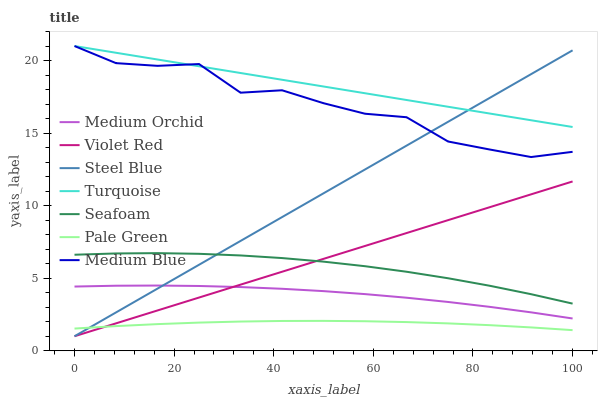Does Pale Green have the minimum area under the curve?
Answer yes or no. Yes. Does Turquoise have the maximum area under the curve?
Answer yes or no. Yes. Does Medium Orchid have the minimum area under the curve?
Answer yes or no. No. Does Medium Orchid have the maximum area under the curve?
Answer yes or no. No. Is Violet Red the smoothest?
Answer yes or no. Yes. Is Medium Blue the roughest?
Answer yes or no. Yes. Is Medium Orchid the smoothest?
Answer yes or no. No. Is Medium Orchid the roughest?
Answer yes or no. No. Does Violet Red have the lowest value?
Answer yes or no. Yes. Does Medium Orchid have the lowest value?
Answer yes or no. No. Does Turquoise have the highest value?
Answer yes or no. Yes. Does Medium Orchid have the highest value?
Answer yes or no. No. Is Pale Green less than Turquoise?
Answer yes or no. Yes. Is Medium Blue greater than Seafoam?
Answer yes or no. Yes. Does Medium Blue intersect Turquoise?
Answer yes or no. Yes. Is Medium Blue less than Turquoise?
Answer yes or no. No. Is Medium Blue greater than Turquoise?
Answer yes or no. No. Does Pale Green intersect Turquoise?
Answer yes or no. No. 